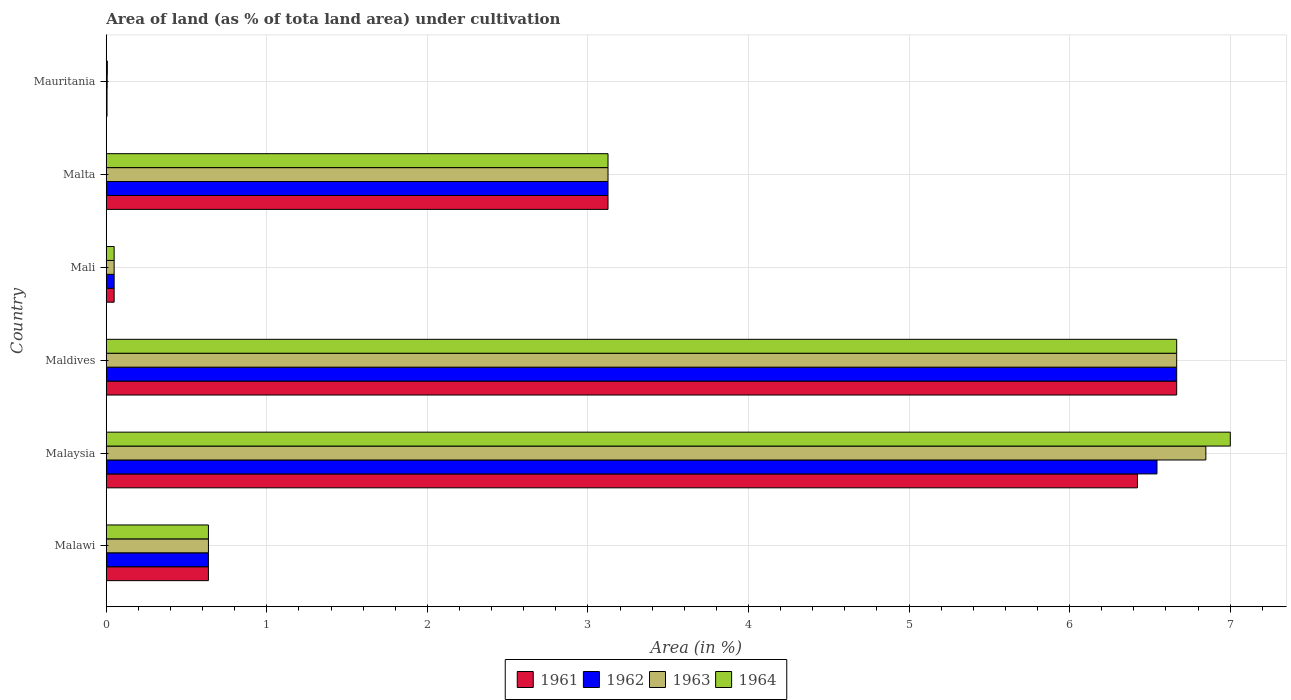How many different coloured bars are there?
Provide a succinct answer. 4. Are the number of bars per tick equal to the number of legend labels?
Keep it short and to the point. Yes. What is the label of the 5th group of bars from the top?
Your answer should be very brief. Malaysia. In how many cases, is the number of bars for a given country not equal to the number of legend labels?
Keep it short and to the point. 0. What is the percentage of land under cultivation in 1962 in Malta?
Make the answer very short. 3.12. Across all countries, what is the maximum percentage of land under cultivation in 1963?
Your answer should be very brief. 6.85. Across all countries, what is the minimum percentage of land under cultivation in 1961?
Make the answer very short. 0. In which country was the percentage of land under cultivation in 1964 maximum?
Your answer should be compact. Malaysia. In which country was the percentage of land under cultivation in 1962 minimum?
Keep it short and to the point. Mauritania. What is the total percentage of land under cultivation in 1964 in the graph?
Make the answer very short. 17.48. What is the difference between the percentage of land under cultivation in 1962 in Malawi and that in Malaysia?
Keep it short and to the point. -5.91. What is the difference between the percentage of land under cultivation in 1964 in Maldives and the percentage of land under cultivation in 1962 in Malta?
Offer a terse response. 3.54. What is the average percentage of land under cultivation in 1962 per country?
Ensure brevity in your answer.  2.84. What is the difference between the percentage of land under cultivation in 1962 and percentage of land under cultivation in 1963 in Malawi?
Make the answer very short. 0. In how many countries, is the percentage of land under cultivation in 1961 greater than 0.8 %?
Your answer should be very brief. 3. What is the ratio of the percentage of land under cultivation in 1962 in Mali to that in Malta?
Give a very brief answer. 0.02. Is the difference between the percentage of land under cultivation in 1962 in Maldives and Malta greater than the difference between the percentage of land under cultivation in 1963 in Maldives and Malta?
Give a very brief answer. No. What is the difference between the highest and the second highest percentage of land under cultivation in 1961?
Offer a terse response. 0.24. What is the difference between the highest and the lowest percentage of land under cultivation in 1964?
Ensure brevity in your answer.  6.99. Is it the case that in every country, the sum of the percentage of land under cultivation in 1963 and percentage of land under cultivation in 1961 is greater than the sum of percentage of land under cultivation in 1962 and percentage of land under cultivation in 1964?
Give a very brief answer. No. What does the 1st bar from the top in Malawi represents?
Your answer should be compact. 1964. Is it the case that in every country, the sum of the percentage of land under cultivation in 1962 and percentage of land under cultivation in 1964 is greater than the percentage of land under cultivation in 1963?
Your answer should be compact. Yes. How many bars are there?
Your answer should be very brief. 24. What is the difference between two consecutive major ticks on the X-axis?
Give a very brief answer. 1. Does the graph contain grids?
Give a very brief answer. Yes. What is the title of the graph?
Give a very brief answer. Area of land (as % of tota land area) under cultivation. What is the label or title of the X-axis?
Give a very brief answer. Area (in %). What is the label or title of the Y-axis?
Offer a terse response. Country. What is the Area (in %) of 1961 in Malawi?
Your response must be concise. 0.64. What is the Area (in %) in 1962 in Malawi?
Offer a terse response. 0.64. What is the Area (in %) in 1963 in Malawi?
Give a very brief answer. 0.64. What is the Area (in %) in 1964 in Malawi?
Provide a succinct answer. 0.64. What is the Area (in %) of 1961 in Malaysia?
Make the answer very short. 6.42. What is the Area (in %) of 1962 in Malaysia?
Make the answer very short. 6.54. What is the Area (in %) in 1963 in Malaysia?
Offer a terse response. 6.85. What is the Area (in %) of 1964 in Malaysia?
Give a very brief answer. 7. What is the Area (in %) of 1961 in Maldives?
Give a very brief answer. 6.67. What is the Area (in %) in 1962 in Maldives?
Offer a terse response. 6.67. What is the Area (in %) in 1963 in Maldives?
Provide a succinct answer. 6.67. What is the Area (in %) in 1964 in Maldives?
Offer a very short reply. 6.67. What is the Area (in %) in 1961 in Mali?
Give a very brief answer. 0.05. What is the Area (in %) of 1962 in Mali?
Your response must be concise. 0.05. What is the Area (in %) in 1963 in Mali?
Ensure brevity in your answer.  0.05. What is the Area (in %) of 1964 in Mali?
Your answer should be very brief. 0.05. What is the Area (in %) of 1961 in Malta?
Give a very brief answer. 3.12. What is the Area (in %) in 1962 in Malta?
Your answer should be very brief. 3.12. What is the Area (in %) of 1963 in Malta?
Your response must be concise. 3.12. What is the Area (in %) of 1964 in Malta?
Give a very brief answer. 3.12. What is the Area (in %) of 1961 in Mauritania?
Provide a succinct answer. 0. What is the Area (in %) in 1962 in Mauritania?
Make the answer very short. 0. What is the Area (in %) of 1963 in Mauritania?
Ensure brevity in your answer.  0.01. What is the Area (in %) in 1964 in Mauritania?
Give a very brief answer. 0.01. Across all countries, what is the maximum Area (in %) of 1961?
Your answer should be very brief. 6.67. Across all countries, what is the maximum Area (in %) of 1962?
Make the answer very short. 6.67. Across all countries, what is the maximum Area (in %) in 1963?
Give a very brief answer. 6.85. Across all countries, what is the maximum Area (in %) of 1964?
Provide a short and direct response. 7. Across all countries, what is the minimum Area (in %) in 1961?
Give a very brief answer. 0. Across all countries, what is the minimum Area (in %) of 1962?
Keep it short and to the point. 0. Across all countries, what is the minimum Area (in %) of 1963?
Your response must be concise. 0.01. Across all countries, what is the minimum Area (in %) in 1964?
Your answer should be compact. 0.01. What is the total Area (in %) of 1961 in the graph?
Give a very brief answer. 16.9. What is the total Area (in %) of 1962 in the graph?
Offer a very short reply. 17.03. What is the total Area (in %) of 1963 in the graph?
Provide a succinct answer. 17.33. What is the total Area (in %) of 1964 in the graph?
Give a very brief answer. 17.48. What is the difference between the Area (in %) of 1961 in Malawi and that in Malaysia?
Make the answer very short. -5.79. What is the difference between the Area (in %) of 1962 in Malawi and that in Malaysia?
Offer a terse response. -5.91. What is the difference between the Area (in %) of 1963 in Malawi and that in Malaysia?
Provide a succinct answer. -6.21. What is the difference between the Area (in %) of 1964 in Malawi and that in Malaysia?
Ensure brevity in your answer.  -6.36. What is the difference between the Area (in %) of 1961 in Malawi and that in Maldives?
Offer a terse response. -6.03. What is the difference between the Area (in %) in 1962 in Malawi and that in Maldives?
Make the answer very short. -6.03. What is the difference between the Area (in %) in 1963 in Malawi and that in Maldives?
Your answer should be very brief. -6.03. What is the difference between the Area (in %) in 1964 in Malawi and that in Maldives?
Offer a terse response. -6.03. What is the difference between the Area (in %) in 1961 in Malawi and that in Mali?
Ensure brevity in your answer.  0.59. What is the difference between the Area (in %) of 1962 in Malawi and that in Mali?
Make the answer very short. 0.59. What is the difference between the Area (in %) in 1963 in Malawi and that in Mali?
Your answer should be very brief. 0.59. What is the difference between the Area (in %) in 1964 in Malawi and that in Mali?
Keep it short and to the point. 0.59. What is the difference between the Area (in %) of 1961 in Malawi and that in Malta?
Provide a short and direct response. -2.49. What is the difference between the Area (in %) in 1962 in Malawi and that in Malta?
Your answer should be compact. -2.49. What is the difference between the Area (in %) of 1963 in Malawi and that in Malta?
Ensure brevity in your answer.  -2.49. What is the difference between the Area (in %) in 1964 in Malawi and that in Malta?
Give a very brief answer. -2.49. What is the difference between the Area (in %) of 1961 in Malawi and that in Mauritania?
Provide a succinct answer. 0.63. What is the difference between the Area (in %) of 1962 in Malawi and that in Mauritania?
Offer a very short reply. 0.63. What is the difference between the Area (in %) of 1963 in Malawi and that in Mauritania?
Your answer should be very brief. 0.63. What is the difference between the Area (in %) in 1964 in Malawi and that in Mauritania?
Offer a very short reply. 0.63. What is the difference between the Area (in %) in 1961 in Malaysia and that in Maldives?
Keep it short and to the point. -0.24. What is the difference between the Area (in %) of 1962 in Malaysia and that in Maldives?
Your response must be concise. -0.12. What is the difference between the Area (in %) of 1963 in Malaysia and that in Maldives?
Your answer should be very brief. 0.18. What is the difference between the Area (in %) in 1964 in Malaysia and that in Maldives?
Keep it short and to the point. 0.33. What is the difference between the Area (in %) in 1961 in Malaysia and that in Mali?
Make the answer very short. 6.37. What is the difference between the Area (in %) in 1962 in Malaysia and that in Mali?
Ensure brevity in your answer.  6.49. What is the difference between the Area (in %) in 1963 in Malaysia and that in Mali?
Make the answer very short. 6.8. What is the difference between the Area (in %) in 1964 in Malaysia and that in Mali?
Your response must be concise. 6.95. What is the difference between the Area (in %) of 1961 in Malaysia and that in Malta?
Your answer should be very brief. 3.3. What is the difference between the Area (in %) of 1962 in Malaysia and that in Malta?
Provide a succinct answer. 3.42. What is the difference between the Area (in %) in 1963 in Malaysia and that in Malta?
Your answer should be very brief. 3.72. What is the difference between the Area (in %) of 1964 in Malaysia and that in Malta?
Offer a terse response. 3.88. What is the difference between the Area (in %) of 1961 in Malaysia and that in Mauritania?
Offer a very short reply. 6.42. What is the difference between the Area (in %) in 1962 in Malaysia and that in Mauritania?
Offer a very short reply. 6.54. What is the difference between the Area (in %) of 1963 in Malaysia and that in Mauritania?
Your response must be concise. 6.84. What is the difference between the Area (in %) in 1964 in Malaysia and that in Mauritania?
Your answer should be very brief. 6.99. What is the difference between the Area (in %) in 1961 in Maldives and that in Mali?
Give a very brief answer. 6.62. What is the difference between the Area (in %) of 1962 in Maldives and that in Mali?
Your answer should be very brief. 6.62. What is the difference between the Area (in %) of 1963 in Maldives and that in Mali?
Make the answer very short. 6.62. What is the difference between the Area (in %) in 1964 in Maldives and that in Mali?
Your answer should be very brief. 6.62. What is the difference between the Area (in %) of 1961 in Maldives and that in Malta?
Provide a short and direct response. 3.54. What is the difference between the Area (in %) in 1962 in Maldives and that in Malta?
Provide a short and direct response. 3.54. What is the difference between the Area (in %) of 1963 in Maldives and that in Malta?
Provide a succinct answer. 3.54. What is the difference between the Area (in %) in 1964 in Maldives and that in Malta?
Provide a short and direct response. 3.54. What is the difference between the Area (in %) of 1961 in Maldives and that in Mauritania?
Offer a terse response. 6.66. What is the difference between the Area (in %) of 1962 in Maldives and that in Mauritania?
Your response must be concise. 6.66. What is the difference between the Area (in %) of 1963 in Maldives and that in Mauritania?
Offer a very short reply. 6.66. What is the difference between the Area (in %) of 1964 in Maldives and that in Mauritania?
Keep it short and to the point. 6.66. What is the difference between the Area (in %) in 1961 in Mali and that in Malta?
Offer a very short reply. -3.08. What is the difference between the Area (in %) of 1962 in Mali and that in Malta?
Make the answer very short. -3.08. What is the difference between the Area (in %) of 1963 in Mali and that in Malta?
Your response must be concise. -3.08. What is the difference between the Area (in %) in 1964 in Mali and that in Malta?
Your response must be concise. -3.08. What is the difference between the Area (in %) of 1961 in Mali and that in Mauritania?
Your response must be concise. 0.04. What is the difference between the Area (in %) of 1962 in Mali and that in Mauritania?
Your response must be concise. 0.04. What is the difference between the Area (in %) in 1963 in Mali and that in Mauritania?
Offer a terse response. 0.04. What is the difference between the Area (in %) in 1964 in Mali and that in Mauritania?
Keep it short and to the point. 0.04. What is the difference between the Area (in %) in 1961 in Malta and that in Mauritania?
Give a very brief answer. 3.12. What is the difference between the Area (in %) in 1962 in Malta and that in Mauritania?
Offer a very short reply. 3.12. What is the difference between the Area (in %) in 1963 in Malta and that in Mauritania?
Make the answer very short. 3.12. What is the difference between the Area (in %) of 1964 in Malta and that in Mauritania?
Provide a succinct answer. 3.12. What is the difference between the Area (in %) in 1961 in Malawi and the Area (in %) in 1962 in Malaysia?
Your answer should be compact. -5.91. What is the difference between the Area (in %) of 1961 in Malawi and the Area (in %) of 1963 in Malaysia?
Ensure brevity in your answer.  -6.21. What is the difference between the Area (in %) of 1961 in Malawi and the Area (in %) of 1964 in Malaysia?
Your answer should be very brief. -6.36. What is the difference between the Area (in %) in 1962 in Malawi and the Area (in %) in 1963 in Malaysia?
Provide a succinct answer. -6.21. What is the difference between the Area (in %) in 1962 in Malawi and the Area (in %) in 1964 in Malaysia?
Your answer should be very brief. -6.36. What is the difference between the Area (in %) in 1963 in Malawi and the Area (in %) in 1964 in Malaysia?
Keep it short and to the point. -6.36. What is the difference between the Area (in %) in 1961 in Malawi and the Area (in %) in 1962 in Maldives?
Your response must be concise. -6.03. What is the difference between the Area (in %) of 1961 in Malawi and the Area (in %) of 1963 in Maldives?
Offer a very short reply. -6.03. What is the difference between the Area (in %) of 1961 in Malawi and the Area (in %) of 1964 in Maldives?
Offer a very short reply. -6.03. What is the difference between the Area (in %) of 1962 in Malawi and the Area (in %) of 1963 in Maldives?
Your answer should be very brief. -6.03. What is the difference between the Area (in %) of 1962 in Malawi and the Area (in %) of 1964 in Maldives?
Offer a very short reply. -6.03. What is the difference between the Area (in %) in 1963 in Malawi and the Area (in %) in 1964 in Maldives?
Your answer should be compact. -6.03. What is the difference between the Area (in %) in 1961 in Malawi and the Area (in %) in 1962 in Mali?
Your answer should be very brief. 0.59. What is the difference between the Area (in %) in 1961 in Malawi and the Area (in %) in 1963 in Mali?
Your response must be concise. 0.59. What is the difference between the Area (in %) in 1961 in Malawi and the Area (in %) in 1964 in Mali?
Offer a terse response. 0.59. What is the difference between the Area (in %) of 1962 in Malawi and the Area (in %) of 1963 in Mali?
Offer a very short reply. 0.59. What is the difference between the Area (in %) in 1962 in Malawi and the Area (in %) in 1964 in Mali?
Provide a short and direct response. 0.59. What is the difference between the Area (in %) of 1963 in Malawi and the Area (in %) of 1964 in Mali?
Provide a short and direct response. 0.59. What is the difference between the Area (in %) in 1961 in Malawi and the Area (in %) in 1962 in Malta?
Your answer should be compact. -2.49. What is the difference between the Area (in %) of 1961 in Malawi and the Area (in %) of 1963 in Malta?
Your answer should be compact. -2.49. What is the difference between the Area (in %) in 1961 in Malawi and the Area (in %) in 1964 in Malta?
Give a very brief answer. -2.49. What is the difference between the Area (in %) of 1962 in Malawi and the Area (in %) of 1963 in Malta?
Your answer should be compact. -2.49. What is the difference between the Area (in %) of 1962 in Malawi and the Area (in %) of 1964 in Malta?
Give a very brief answer. -2.49. What is the difference between the Area (in %) of 1963 in Malawi and the Area (in %) of 1964 in Malta?
Offer a very short reply. -2.49. What is the difference between the Area (in %) in 1961 in Malawi and the Area (in %) in 1962 in Mauritania?
Give a very brief answer. 0.63. What is the difference between the Area (in %) in 1961 in Malawi and the Area (in %) in 1963 in Mauritania?
Offer a very short reply. 0.63. What is the difference between the Area (in %) in 1961 in Malawi and the Area (in %) in 1964 in Mauritania?
Your response must be concise. 0.63. What is the difference between the Area (in %) in 1962 in Malawi and the Area (in %) in 1963 in Mauritania?
Offer a terse response. 0.63. What is the difference between the Area (in %) of 1962 in Malawi and the Area (in %) of 1964 in Mauritania?
Offer a terse response. 0.63. What is the difference between the Area (in %) of 1963 in Malawi and the Area (in %) of 1964 in Mauritania?
Offer a very short reply. 0.63. What is the difference between the Area (in %) in 1961 in Malaysia and the Area (in %) in 1962 in Maldives?
Provide a short and direct response. -0.24. What is the difference between the Area (in %) of 1961 in Malaysia and the Area (in %) of 1963 in Maldives?
Your answer should be very brief. -0.24. What is the difference between the Area (in %) in 1961 in Malaysia and the Area (in %) in 1964 in Maldives?
Keep it short and to the point. -0.24. What is the difference between the Area (in %) in 1962 in Malaysia and the Area (in %) in 1963 in Maldives?
Give a very brief answer. -0.12. What is the difference between the Area (in %) of 1962 in Malaysia and the Area (in %) of 1964 in Maldives?
Offer a very short reply. -0.12. What is the difference between the Area (in %) of 1963 in Malaysia and the Area (in %) of 1964 in Maldives?
Give a very brief answer. 0.18. What is the difference between the Area (in %) in 1961 in Malaysia and the Area (in %) in 1962 in Mali?
Provide a succinct answer. 6.37. What is the difference between the Area (in %) of 1961 in Malaysia and the Area (in %) of 1963 in Mali?
Give a very brief answer. 6.37. What is the difference between the Area (in %) in 1961 in Malaysia and the Area (in %) in 1964 in Mali?
Keep it short and to the point. 6.37. What is the difference between the Area (in %) of 1962 in Malaysia and the Area (in %) of 1963 in Mali?
Ensure brevity in your answer.  6.49. What is the difference between the Area (in %) of 1962 in Malaysia and the Area (in %) of 1964 in Mali?
Keep it short and to the point. 6.49. What is the difference between the Area (in %) in 1963 in Malaysia and the Area (in %) in 1964 in Mali?
Your answer should be compact. 6.8. What is the difference between the Area (in %) of 1961 in Malaysia and the Area (in %) of 1962 in Malta?
Provide a short and direct response. 3.3. What is the difference between the Area (in %) in 1961 in Malaysia and the Area (in %) in 1963 in Malta?
Offer a very short reply. 3.3. What is the difference between the Area (in %) of 1961 in Malaysia and the Area (in %) of 1964 in Malta?
Provide a short and direct response. 3.3. What is the difference between the Area (in %) in 1962 in Malaysia and the Area (in %) in 1963 in Malta?
Give a very brief answer. 3.42. What is the difference between the Area (in %) of 1962 in Malaysia and the Area (in %) of 1964 in Malta?
Your answer should be compact. 3.42. What is the difference between the Area (in %) in 1963 in Malaysia and the Area (in %) in 1964 in Malta?
Your answer should be very brief. 3.72. What is the difference between the Area (in %) in 1961 in Malaysia and the Area (in %) in 1962 in Mauritania?
Your answer should be very brief. 6.42. What is the difference between the Area (in %) in 1961 in Malaysia and the Area (in %) in 1963 in Mauritania?
Your response must be concise. 6.42. What is the difference between the Area (in %) in 1961 in Malaysia and the Area (in %) in 1964 in Mauritania?
Provide a succinct answer. 6.42. What is the difference between the Area (in %) in 1962 in Malaysia and the Area (in %) in 1963 in Mauritania?
Ensure brevity in your answer.  6.54. What is the difference between the Area (in %) of 1962 in Malaysia and the Area (in %) of 1964 in Mauritania?
Keep it short and to the point. 6.54. What is the difference between the Area (in %) of 1963 in Malaysia and the Area (in %) of 1964 in Mauritania?
Your answer should be compact. 6.84. What is the difference between the Area (in %) of 1961 in Maldives and the Area (in %) of 1962 in Mali?
Provide a short and direct response. 6.62. What is the difference between the Area (in %) in 1961 in Maldives and the Area (in %) in 1963 in Mali?
Offer a very short reply. 6.62. What is the difference between the Area (in %) in 1961 in Maldives and the Area (in %) in 1964 in Mali?
Offer a terse response. 6.62. What is the difference between the Area (in %) of 1962 in Maldives and the Area (in %) of 1963 in Mali?
Give a very brief answer. 6.62. What is the difference between the Area (in %) of 1962 in Maldives and the Area (in %) of 1964 in Mali?
Make the answer very short. 6.62. What is the difference between the Area (in %) in 1963 in Maldives and the Area (in %) in 1964 in Mali?
Give a very brief answer. 6.62. What is the difference between the Area (in %) of 1961 in Maldives and the Area (in %) of 1962 in Malta?
Ensure brevity in your answer.  3.54. What is the difference between the Area (in %) of 1961 in Maldives and the Area (in %) of 1963 in Malta?
Your response must be concise. 3.54. What is the difference between the Area (in %) of 1961 in Maldives and the Area (in %) of 1964 in Malta?
Provide a short and direct response. 3.54. What is the difference between the Area (in %) of 1962 in Maldives and the Area (in %) of 1963 in Malta?
Provide a short and direct response. 3.54. What is the difference between the Area (in %) of 1962 in Maldives and the Area (in %) of 1964 in Malta?
Provide a short and direct response. 3.54. What is the difference between the Area (in %) of 1963 in Maldives and the Area (in %) of 1964 in Malta?
Offer a very short reply. 3.54. What is the difference between the Area (in %) in 1961 in Maldives and the Area (in %) in 1962 in Mauritania?
Your response must be concise. 6.66. What is the difference between the Area (in %) of 1961 in Maldives and the Area (in %) of 1963 in Mauritania?
Make the answer very short. 6.66. What is the difference between the Area (in %) of 1961 in Maldives and the Area (in %) of 1964 in Mauritania?
Keep it short and to the point. 6.66. What is the difference between the Area (in %) of 1962 in Maldives and the Area (in %) of 1963 in Mauritania?
Your response must be concise. 6.66. What is the difference between the Area (in %) of 1962 in Maldives and the Area (in %) of 1964 in Mauritania?
Give a very brief answer. 6.66. What is the difference between the Area (in %) of 1963 in Maldives and the Area (in %) of 1964 in Mauritania?
Provide a short and direct response. 6.66. What is the difference between the Area (in %) in 1961 in Mali and the Area (in %) in 1962 in Malta?
Make the answer very short. -3.08. What is the difference between the Area (in %) of 1961 in Mali and the Area (in %) of 1963 in Malta?
Offer a very short reply. -3.08. What is the difference between the Area (in %) in 1961 in Mali and the Area (in %) in 1964 in Malta?
Offer a very short reply. -3.08. What is the difference between the Area (in %) in 1962 in Mali and the Area (in %) in 1963 in Malta?
Your response must be concise. -3.08. What is the difference between the Area (in %) in 1962 in Mali and the Area (in %) in 1964 in Malta?
Your response must be concise. -3.08. What is the difference between the Area (in %) of 1963 in Mali and the Area (in %) of 1964 in Malta?
Ensure brevity in your answer.  -3.08. What is the difference between the Area (in %) in 1961 in Mali and the Area (in %) in 1962 in Mauritania?
Ensure brevity in your answer.  0.04. What is the difference between the Area (in %) in 1961 in Mali and the Area (in %) in 1963 in Mauritania?
Provide a short and direct response. 0.04. What is the difference between the Area (in %) in 1961 in Mali and the Area (in %) in 1964 in Mauritania?
Keep it short and to the point. 0.04. What is the difference between the Area (in %) of 1962 in Mali and the Area (in %) of 1963 in Mauritania?
Ensure brevity in your answer.  0.04. What is the difference between the Area (in %) of 1962 in Mali and the Area (in %) of 1964 in Mauritania?
Ensure brevity in your answer.  0.04. What is the difference between the Area (in %) of 1963 in Mali and the Area (in %) of 1964 in Mauritania?
Your response must be concise. 0.04. What is the difference between the Area (in %) of 1961 in Malta and the Area (in %) of 1962 in Mauritania?
Your response must be concise. 3.12. What is the difference between the Area (in %) in 1961 in Malta and the Area (in %) in 1963 in Mauritania?
Your answer should be very brief. 3.12. What is the difference between the Area (in %) in 1961 in Malta and the Area (in %) in 1964 in Mauritania?
Your response must be concise. 3.12. What is the difference between the Area (in %) of 1962 in Malta and the Area (in %) of 1963 in Mauritania?
Offer a terse response. 3.12. What is the difference between the Area (in %) in 1962 in Malta and the Area (in %) in 1964 in Mauritania?
Ensure brevity in your answer.  3.12. What is the difference between the Area (in %) in 1963 in Malta and the Area (in %) in 1964 in Mauritania?
Provide a short and direct response. 3.12. What is the average Area (in %) in 1961 per country?
Keep it short and to the point. 2.82. What is the average Area (in %) of 1962 per country?
Your answer should be very brief. 2.84. What is the average Area (in %) in 1963 per country?
Provide a short and direct response. 2.89. What is the average Area (in %) in 1964 per country?
Provide a succinct answer. 2.91. What is the difference between the Area (in %) in 1961 and Area (in %) in 1962 in Malawi?
Your response must be concise. 0. What is the difference between the Area (in %) of 1961 and Area (in %) of 1964 in Malawi?
Offer a terse response. 0. What is the difference between the Area (in %) of 1962 and Area (in %) of 1963 in Malawi?
Offer a very short reply. 0. What is the difference between the Area (in %) of 1962 and Area (in %) of 1964 in Malawi?
Your answer should be very brief. 0. What is the difference between the Area (in %) in 1961 and Area (in %) in 1962 in Malaysia?
Provide a short and direct response. -0.12. What is the difference between the Area (in %) in 1961 and Area (in %) in 1963 in Malaysia?
Your answer should be compact. -0.43. What is the difference between the Area (in %) of 1961 and Area (in %) of 1964 in Malaysia?
Offer a terse response. -0.58. What is the difference between the Area (in %) in 1962 and Area (in %) in 1963 in Malaysia?
Your answer should be compact. -0.3. What is the difference between the Area (in %) in 1962 and Area (in %) in 1964 in Malaysia?
Your response must be concise. -0.46. What is the difference between the Area (in %) in 1963 and Area (in %) in 1964 in Malaysia?
Provide a succinct answer. -0.15. What is the difference between the Area (in %) in 1961 and Area (in %) in 1962 in Maldives?
Keep it short and to the point. 0. What is the difference between the Area (in %) of 1961 and Area (in %) of 1963 in Maldives?
Make the answer very short. 0. What is the difference between the Area (in %) in 1961 and Area (in %) in 1964 in Maldives?
Give a very brief answer. 0. What is the difference between the Area (in %) in 1962 and Area (in %) in 1963 in Maldives?
Offer a terse response. 0. What is the difference between the Area (in %) of 1962 and Area (in %) of 1964 in Maldives?
Ensure brevity in your answer.  0. What is the difference between the Area (in %) in 1961 and Area (in %) in 1962 in Mali?
Your response must be concise. 0. What is the difference between the Area (in %) of 1961 and Area (in %) of 1963 in Mali?
Offer a terse response. 0. What is the difference between the Area (in %) in 1962 and Area (in %) in 1964 in Mali?
Offer a terse response. 0. What is the difference between the Area (in %) in 1961 and Area (in %) in 1962 in Malta?
Offer a terse response. 0. What is the difference between the Area (in %) in 1961 and Area (in %) in 1963 in Malta?
Give a very brief answer. 0. What is the difference between the Area (in %) of 1962 and Area (in %) of 1963 in Malta?
Provide a succinct answer. 0. What is the difference between the Area (in %) of 1961 and Area (in %) of 1962 in Mauritania?
Keep it short and to the point. 0. What is the difference between the Area (in %) of 1961 and Area (in %) of 1963 in Mauritania?
Make the answer very short. -0. What is the difference between the Area (in %) in 1961 and Area (in %) in 1964 in Mauritania?
Your answer should be very brief. -0. What is the difference between the Area (in %) of 1962 and Area (in %) of 1963 in Mauritania?
Offer a very short reply. -0. What is the difference between the Area (in %) in 1962 and Area (in %) in 1964 in Mauritania?
Offer a very short reply. -0. What is the difference between the Area (in %) of 1963 and Area (in %) of 1964 in Mauritania?
Give a very brief answer. -0. What is the ratio of the Area (in %) of 1961 in Malawi to that in Malaysia?
Keep it short and to the point. 0.1. What is the ratio of the Area (in %) in 1962 in Malawi to that in Malaysia?
Offer a very short reply. 0.1. What is the ratio of the Area (in %) of 1963 in Malawi to that in Malaysia?
Your response must be concise. 0.09. What is the ratio of the Area (in %) in 1964 in Malawi to that in Malaysia?
Keep it short and to the point. 0.09. What is the ratio of the Area (in %) of 1961 in Malawi to that in Maldives?
Provide a short and direct response. 0.1. What is the ratio of the Area (in %) of 1962 in Malawi to that in Maldives?
Give a very brief answer. 0.1. What is the ratio of the Area (in %) in 1963 in Malawi to that in Maldives?
Provide a short and direct response. 0.1. What is the ratio of the Area (in %) of 1964 in Malawi to that in Maldives?
Your response must be concise. 0.1. What is the ratio of the Area (in %) in 1961 in Malawi to that in Mali?
Give a very brief answer. 12.94. What is the ratio of the Area (in %) in 1962 in Malawi to that in Mali?
Provide a succinct answer. 12.94. What is the ratio of the Area (in %) in 1963 in Malawi to that in Mali?
Your answer should be compact. 12.94. What is the ratio of the Area (in %) of 1964 in Malawi to that in Mali?
Make the answer very short. 12.94. What is the ratio of the Area (in %) in 1961 in Malawi to that in Malta?
Ensure brevity in your answer.  0.2. What is the ratio of the Area (in %) in 1962 in Malawi to that in Malta?
Your response must be concise. 0.2. What is the ratio of the Area (in %) in 1963 in Malawi to that in Malta?
Offer a very short reply. 0.2. What is the ratio of the Area (in %) in 1964 in Malawi to that in Malta?
Make the answer very short. 0.2. What is the ratio of the Area (in %) of 1961 in Malawi to that in Mauritania?
Give a very brief answer. 131.19. What is the ratio of the Area (in %) of 1962 in Malawi to that in Mauritania?
Keep it short and to the point. 131.19. What is the ratio of the Area (in %) of 1963 in Malawi to that in Mauritania?
Your answer should be very brief. 109.32. What is the ratio of the Area (in %) of 1964 in Malawi to that in Mauritania?
Keep it short and to the point. 93.71. What is the ratio of the Area (in %) in 1961 in Malaysia to that in Maldives?
Ensure brevity in your answer.  0.96. What is the ratio of the Area (in %) of 1962 in Malaysia to that in Maldives?
Offer a terse response. 0.98. What is the ratio of the Area (in %) of 1963 in Malaysia to that in Maldives?
Provide a succinct answer. 1.03. What is the ratio of the Area (in %) of 1964 in Malaysia to that in Maldives?
Your answer should be very brief. 1.05. What is the ratio of the Area (in %) in 1961 in Malaysia to that in Mali?
Your answer should be very brief. 130.6. What is the ratio of the Area (in %) of 1962 in Malaysia to that in Mali?
Your answer should be compact. 133.08. What is the ratio of the Area (in %) in 1963 in Malaysia to that in Mali?
Your response must be concise. 139.27. What is the ratio of the Area (in %) in 1964 in Malaysia to that in Mali?
Offer a terse response. 142.36. What is the ratio of the Area (in %) of 1961 in Malaysia to that in Malta?
Your response must be concise. 2.06. What is the ratio of the Area (in %) of 1962 in Malaysia to that in Malta?
Offer a very short reply. 2.09. What is the ratio of the Area (in %) of 1963 in Malaysia to that in Malta?
Offer a very short reply. 2.19. What is the ratio of the Area (in %) in 1964 in Malaysia to that in Malta?
Give a very brief answer. 2.24. What is the ratio of the Area (in %) of 1961 in Malaysia to that in Mauritania?
Give a very brief answer. 1323.86. What is the ratio of the Area (in %) of 1962 in Malaysia to that in Mauritania?
Your answer should be very brief. 1348.96. What is the ratio of the Area (in %) of 1963 in Malaysia to that in Mauritania?
Give a very brief answer. 1176.42. What is the ratio of the Area (in %) of 1964 in Malaysia to that in Mauritania?
Provide a succinct answer. 1030.77. What is the ratio of the Area (in %) in 1961 in Maldives to that in Mali?
Offer a very short reply. 135.58. What is the ratio of the Area (in %) in 1962 in Maldives to that in Mali?
Your answer should be very brief. 135.58. What is the ratio of the Area (in %) in 1963 in Maldives to that in Mali?
Your answer should be very brief. 135.58. What is the ratio of the Area (in %) in 1964 in Maldives to that in Mali?
Provide a succinct answer. 135.58. What is the ratio of the Area (in %) in 1961 in Maldives to that in Malta?
Provide a succinct answer. 2.13. What is the ratio of the Area (in %) in 1962 in Maldives to that in Malta?
Offer a terse response. 2.13. What is the ratio of the Area (in %) in 1963 in Maldives to that in Malta?
Offer a terse response. 2.13. What is the ratio of the Area (in %) in 1964 in Maldives to that in Malta?
Your answer should be very brief. 2.13. What is the ratio of the Area (in %) in 1961 in Maldives to that in Mauritania?
Offer a very short reply. 1374.27. What is the ratio of the Area (in %) in 1962 in Maldives to that in Mauritania?
Offer a very short reply. 1374.27. What is the ratio of the Area (in %) of 1963 in Maldives to that in Mauritania?
Provide a succinct answer. 1145.22. What is the ratio of the Area (in %) in 1964 in Maldives to that in Mauritania?
Provide a short and direct response. 981.62. What is the ratio of the Area (in %) in 1961 in Mali to that in Malta?
Offer a terse response. 0.02. What is the ratio of the Area (in %) in 1962 in Mali to that in Malta?
Offer a very short reply. 0.02. What is the ratio of the Area (in %) of 1963 in Mali to that in Malta?
Give a very brief answer. 0.02. What is the ratio of the Area (in %) of 1964 in Mali to that in Malta?
Keep it short and to the point. 0.02. What is the ratio of the Area (in %) in 1961 in Mali to that in Mauritania?
Provide a short and direct response. 10.14. What is the ratio of the Area (in %) of 1962 in Mali to that in Mauritania?
Your answer should be compact. 10.14. What is the ratio of the Area (in %) of 1963 in Mali to that in Mauritania?
Keep it short and to the point. 8.45. What is the ratio of the Area (in %) in 1964 in Mali to that in Mauritania?
Your response must be concise. 7.24. What is the ratio of the Area (in %) of 1961 in Malta to that in Mauritania?
Offer a terse response. 644.19. What is the ratio of the Area (in %) in 1962 in Malta to that in Mauritania?
Your answer should be compact. 644.19. What is the ratio of the Area (in %) of 1963 in Malta to that in Mauritania?
Keep it short and to the point. 536.82. What is the ratio of the Area (in %) in 1964 in Malta to that in Mauritania?
Offer a very short reply. 460.13. What is the difference between the highest and the second highest Area (in %) in 1961?
Offer a terse response. 0.24. What is the difference between the highest and the second highest Area (in %) in 1962?
Offer a terse response. 0.12. What is the difference between the highest and the second highest Area (in %) in 1963?
Offer a terse response. 0.18. What is the difference between the highest and the second highest Area (in %) of 1964?
Offer a terse response. 0.33. What is the difference between the highest and the lowest Area (in %) in 1961?
Offer a very short reply. 6.66. What is the difference between the highest and the lowest Area (in %) in 1962?
Your answer should be compact. 6.66. What is the difference between the highest and the lowest Area (in %) of 1963?
Your answer should be compact. 6.84. What is the difference between the highest and the lowest Area (in %) in 1964?
Make the answer very short. 6.99. 